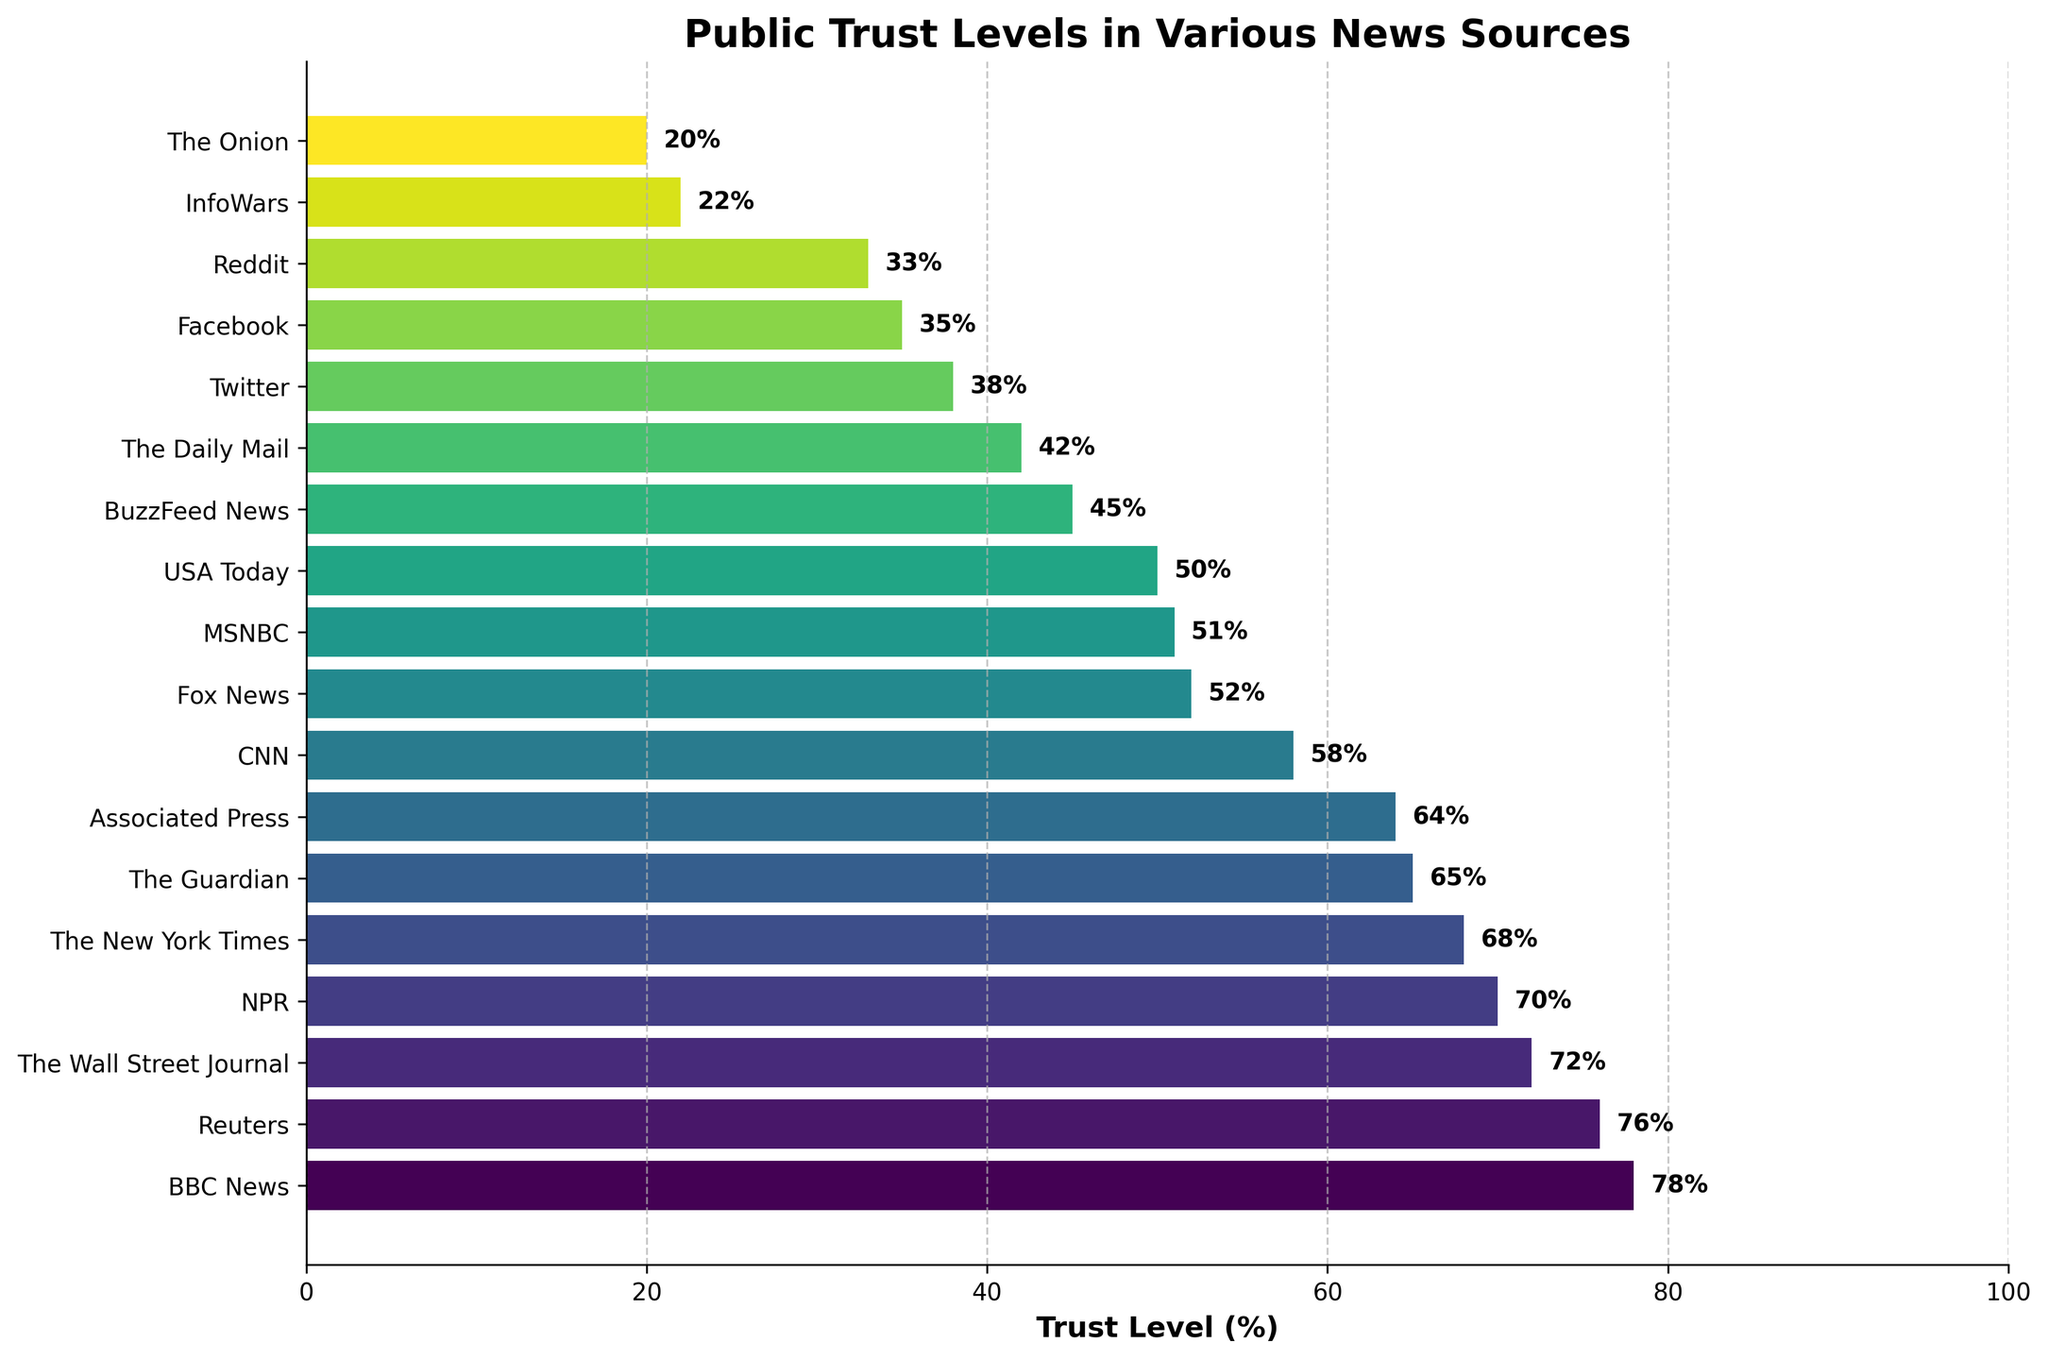What is the trust level of BBC News? The bar representing BBC News reaches the 78% mark on the x-axis, which means the trust level is 78%.
Answer: 78% Which news source has the lowest trust level? The lowest bar corresponds to The Onion, which means it has the lowest trust level.
Answer: The Onion How does the trust level of Fox News compare to CNN? The bar for Fox News is at 52%, while CNN is at 58%. This means Fox News has a lower trust level compared to CNN.
Answer: CNN has a higher trust level than Fox News How much higher is the trust level of NPR compared to The Guardian? NPR has a trust level of 70%, and The Guardian has 65%. The difference between them is 70% - 65% = 5%.
Answer: 5% Which sources have a trust level between 60% and 70%? By looking at the bars that fall within the 60-70% range, Associated Press (64%), The Guardian (65%), and The New York Times (68%) fit this criterion.
Answer: Associated Press, The Guardian, The New York Times What is the average trust level of Reuters, The Guardian, and BuzzFeed News? Reuters has 76%, The Guardian has 65%, and BuzzFeed News has 45%. The sum is 76 + 65 + 45 = 186. Dividing by 3, the average is 186/3 = 62%.
Answer: 62% Is the trust level of Facebook greater or less than half of the trust level of NPR? Facebook has a trust level of 35%, while NPR has 70%. Half of NPR's trust level is 70/2 = 35%. Since Facebook's trust level is exactly 35%, it is equal to half of NPR's trust level.
Answer: Equal What is the difference in trust level between USA Today and The Daily Mail? USA Today has 50%, and The Daily Mail has 42%. The difference is 50% - 42% = 8%.
Answer: 8% What is the range of trust levels for all the news sources shown? The highest trust level is 78% (BBC News) and the lowest is 20% (The Onion). The range is 78% - 20% = 58%.
Answer: 58% Which two news sources have trust levels closest to each other? Looking at the bars, Fox News (52%) and MSNBC (51%) have trust levels that are very close, with only a 1% difference.
Answer: Fox News and MSNBC 